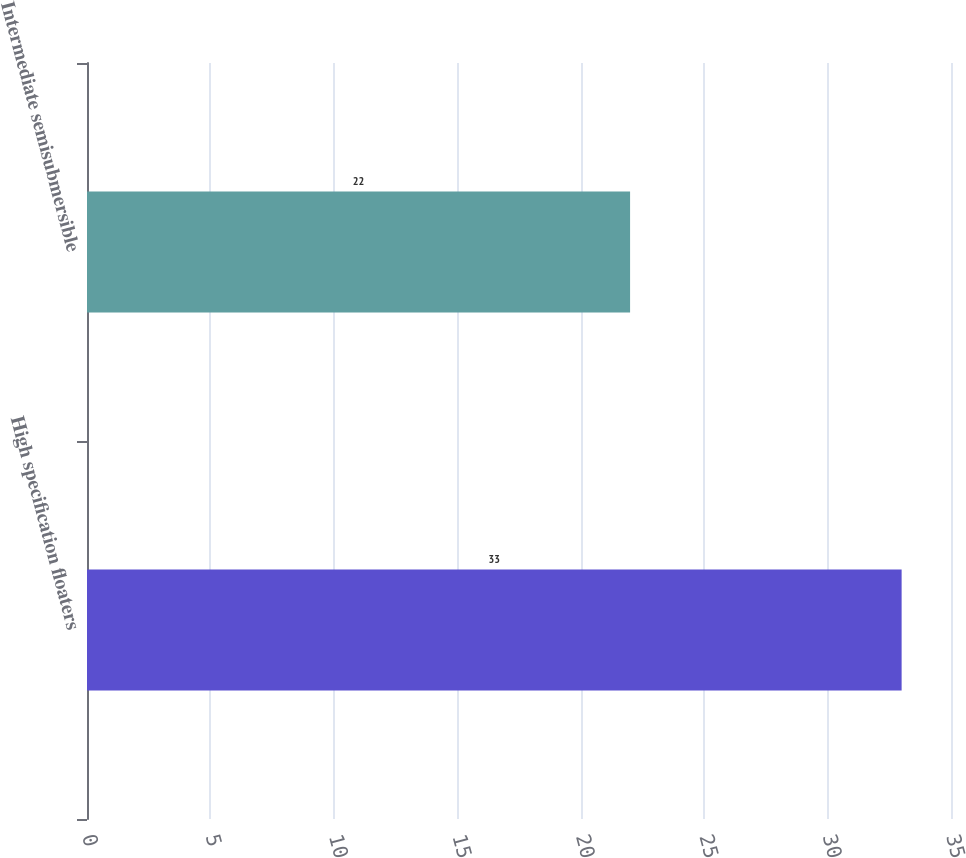<chart> <loc_0><loc_0><loc_500><loc_500><bar_chart><fcel>High specification floaters<fcel>Intermediate semisubmersible<nl><fcel>33<fcel>22<nl></chart> 